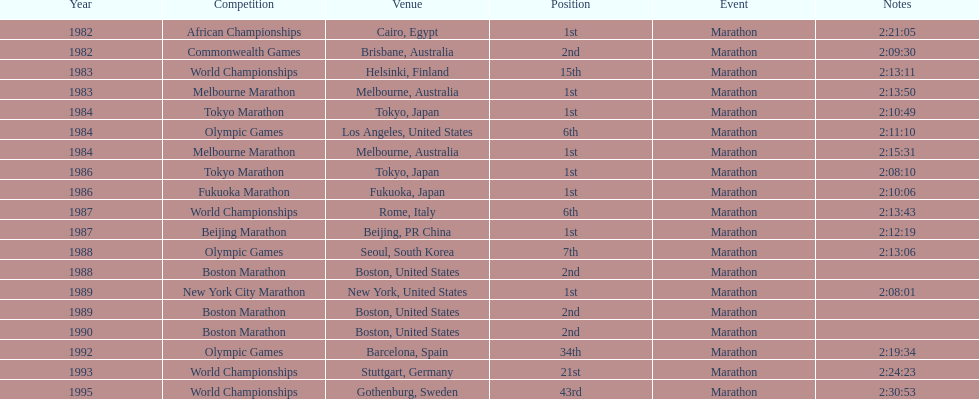In what year did the runner participate in the most marathons? 1984. Could you help me parse every detail presented in this table? {'header': ['Year', 'Competition', 'Venue', 'Position', 'Event', 'Notes'], 'rows': [['1982', 'African Championships', 'Cairo, Egypt', '1st', 'Marathon', '2:21:05'], ['1982', 'Commonwealth Games', 'Brisbane, Australia', '2nd', 'Marathon', '2:09:30'], ['1983', 'World Championships', 'Helsinki, Finland', '15th', 'Marathon', '2:13:11'], ['1983', 'Melbourne Marathon', 'Melbourne, Australia', '1st', 'Marathon', '2:13:50'], ['1984', 'Tokyo Marathon', 'Tokyo, Japan', '1st', 'Marathon', '2:10:49'], ['1984', 'Olympic Games', 'Los Angeles, United States', '6th', 'Marathon', '2:11:10'], ['1984', 'Melbourne Marathon', 'Melbourne, Australia', '1st', 'Marathon', '2:15:31'], ['1986', 'Tokyo Marathon', 'Tokyo, Japan', '1st', 'Marathon', '2:08:10'], ['1986', 'Fukuoka Marathon', 'Fukuoka, Japan', '1st', 'Marathon', '2:10:06'], ['1987', 'World Championships', 'Rome, Italy', '6th', 'Marathon', '2:13:43'], ['1987', 'Beijing Marathon', 'Beijing, PR China', '1st', 'Marathon', '2:12:19'], ['1988', 'Olympic Games', 'Seoul, South Korea', '7th', 'Marathon', '2:13:06'], ['1988', 'Boston Marathon', 'Boston, United States', '2nd', 'Marathon', ''], ['1989', 'New York City Marathon', 'New York, United States', '1st', 'Marathon', '2:08:01'], ['1989', 'Boston Marathon', 'Boston, United States', '2nd', 'Marathon', ''], ['1990', 'Boston Marathon', 'Boston, United States', '2nd', 'Marathon', ''], ['1992', 'Olympic Games', 'Barcelona, Spain', '34th', 'Marathon', '2:19:34'], ['1993', 'World Championships', 'Stuttgart, Germany', '21st', 'Marathon', '2:24:23'], ['1995', 'World Championships', 'Gothenburg, Sweden', '43rd', 'Marathon', '2:30:53']]} 